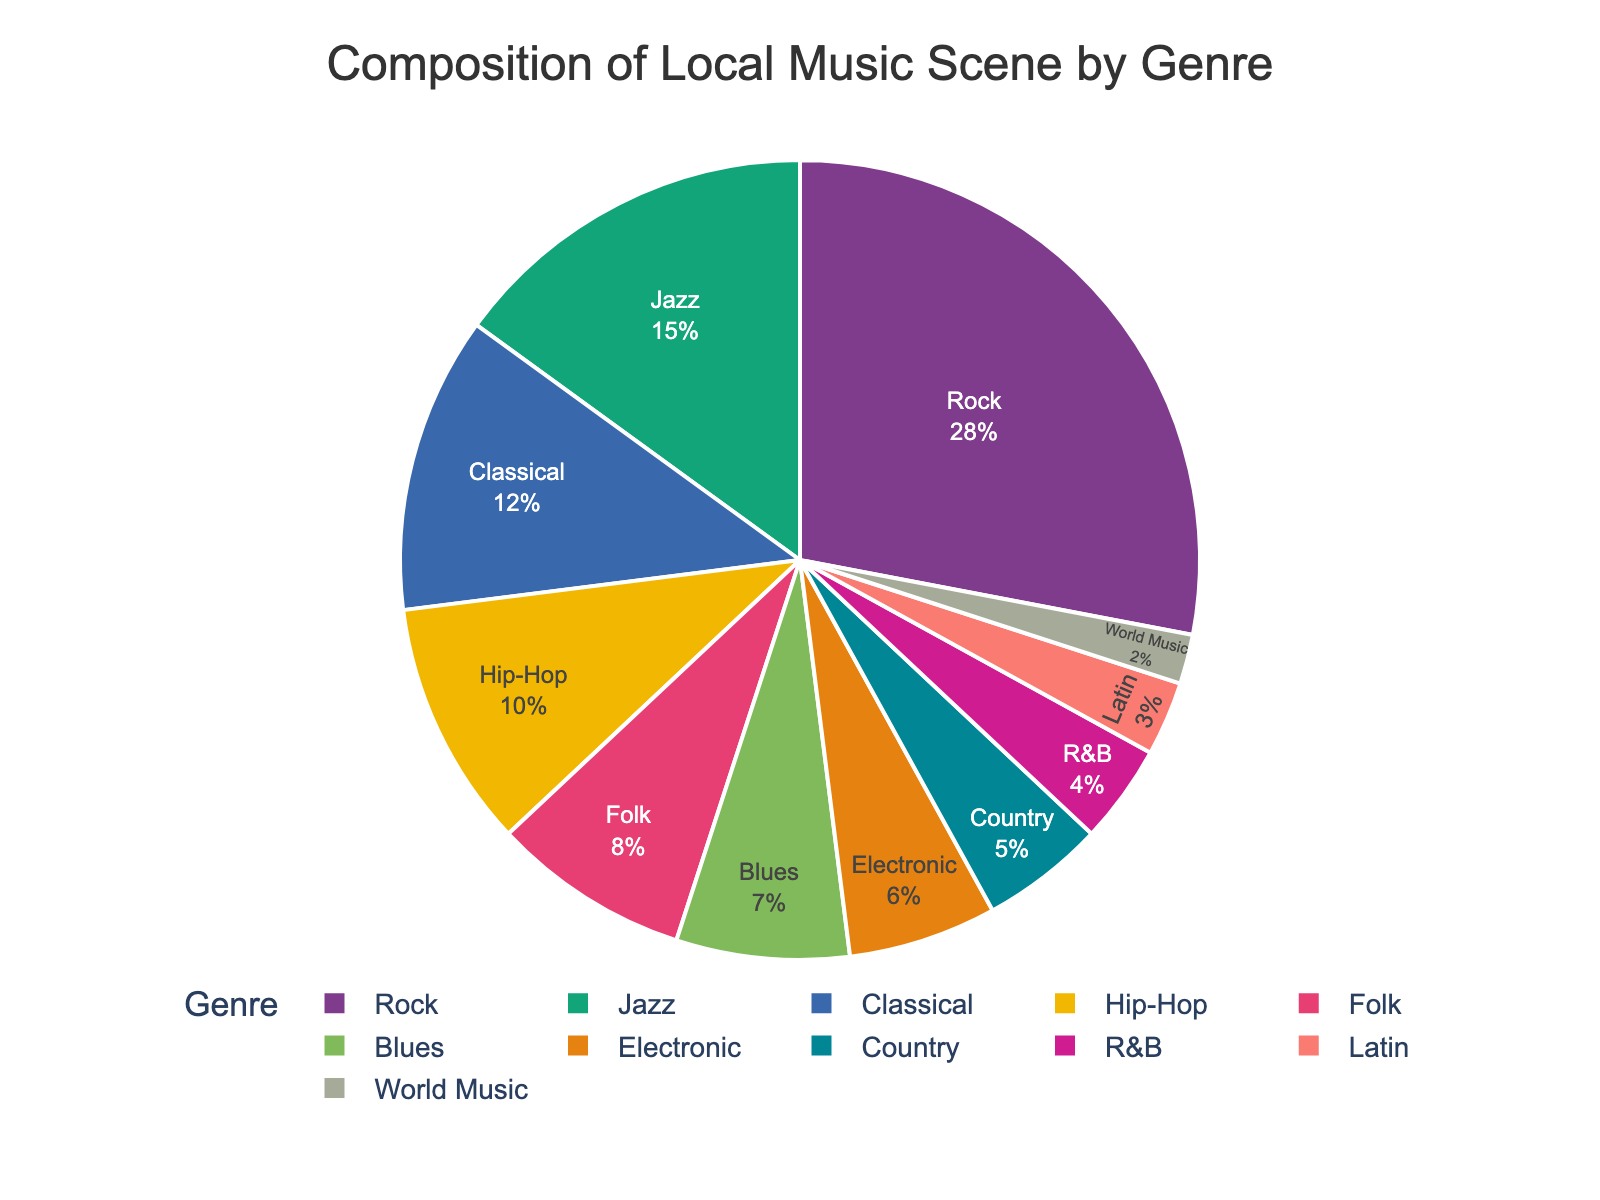Which genre is the most prominent in the local music scene? The pie chart shows the composition of the local music scene by genre, and the segment representing Rock is the largest. Hence, Rock is the most prominent genre.
Answer: Rock What percentage of the local music scene is made up of Jazz and Classical combined? The pie chart indicates that Jazz accounts for 15% and Classical accounts for 12%. Summing these two percentages, 15% + 12% = 27%.
Answer: 27% Is the percentage of Hip-Hop higher than the percentage of Folk? Referring to the pie chart, Hip-Hop accounts for 10% while Folk accounts for 8%. Since 10% is greater than 8%, Hip-Hop has a higher percentage than Folk.
Answer: Yes Which genres make up at least 10% of the local music scene each? The pie chart shows that Rock (28%), Jazz (15%), Classical (12%), and Hip-Hop (10%) each make up at least 10% of the local music scene.
Answer: Rock, Jazz, Classical, Hip-Hop How does the percentage of Blues compare to that of Latin music? The pie chart indicates that Blues accounts for 7% while Latin accounts for 3%. Since 7% is greater than 3%, Blues has a higher percentage than Latin.
Answer: Blues has a higher percentage than Latin What is the combined percentage of genres that account for less than 5% each? Referring to the pie chart, R&B (4%), Latin (3%), and World Music (2%) each account for less than 5%. Summing these percentages, 4% + 3% + 2% = 9%.
Answer: 9% Out of the genres listed, which one has the smallest representation in the local music scene? From the pie chart, the segment for World Music is the smallest, representing 2%. Hence, World Music has the smallest representation.
Answer: World Music How much larger is the percentage of Rock compared to Country? The pie chart shows Rock at 28% and Country at 5%. The difference is calculated by subtracting the percentage of Country from Rock, 28% - 5% = 23%.
Answer: 23% If you were to combine the percentages of Electronic and R&B, what would the total be? The pie chart indicates Electronic at 6% and R&B at 4%. Adding these, 6% + 4% = 10%.
Answer: 10% 